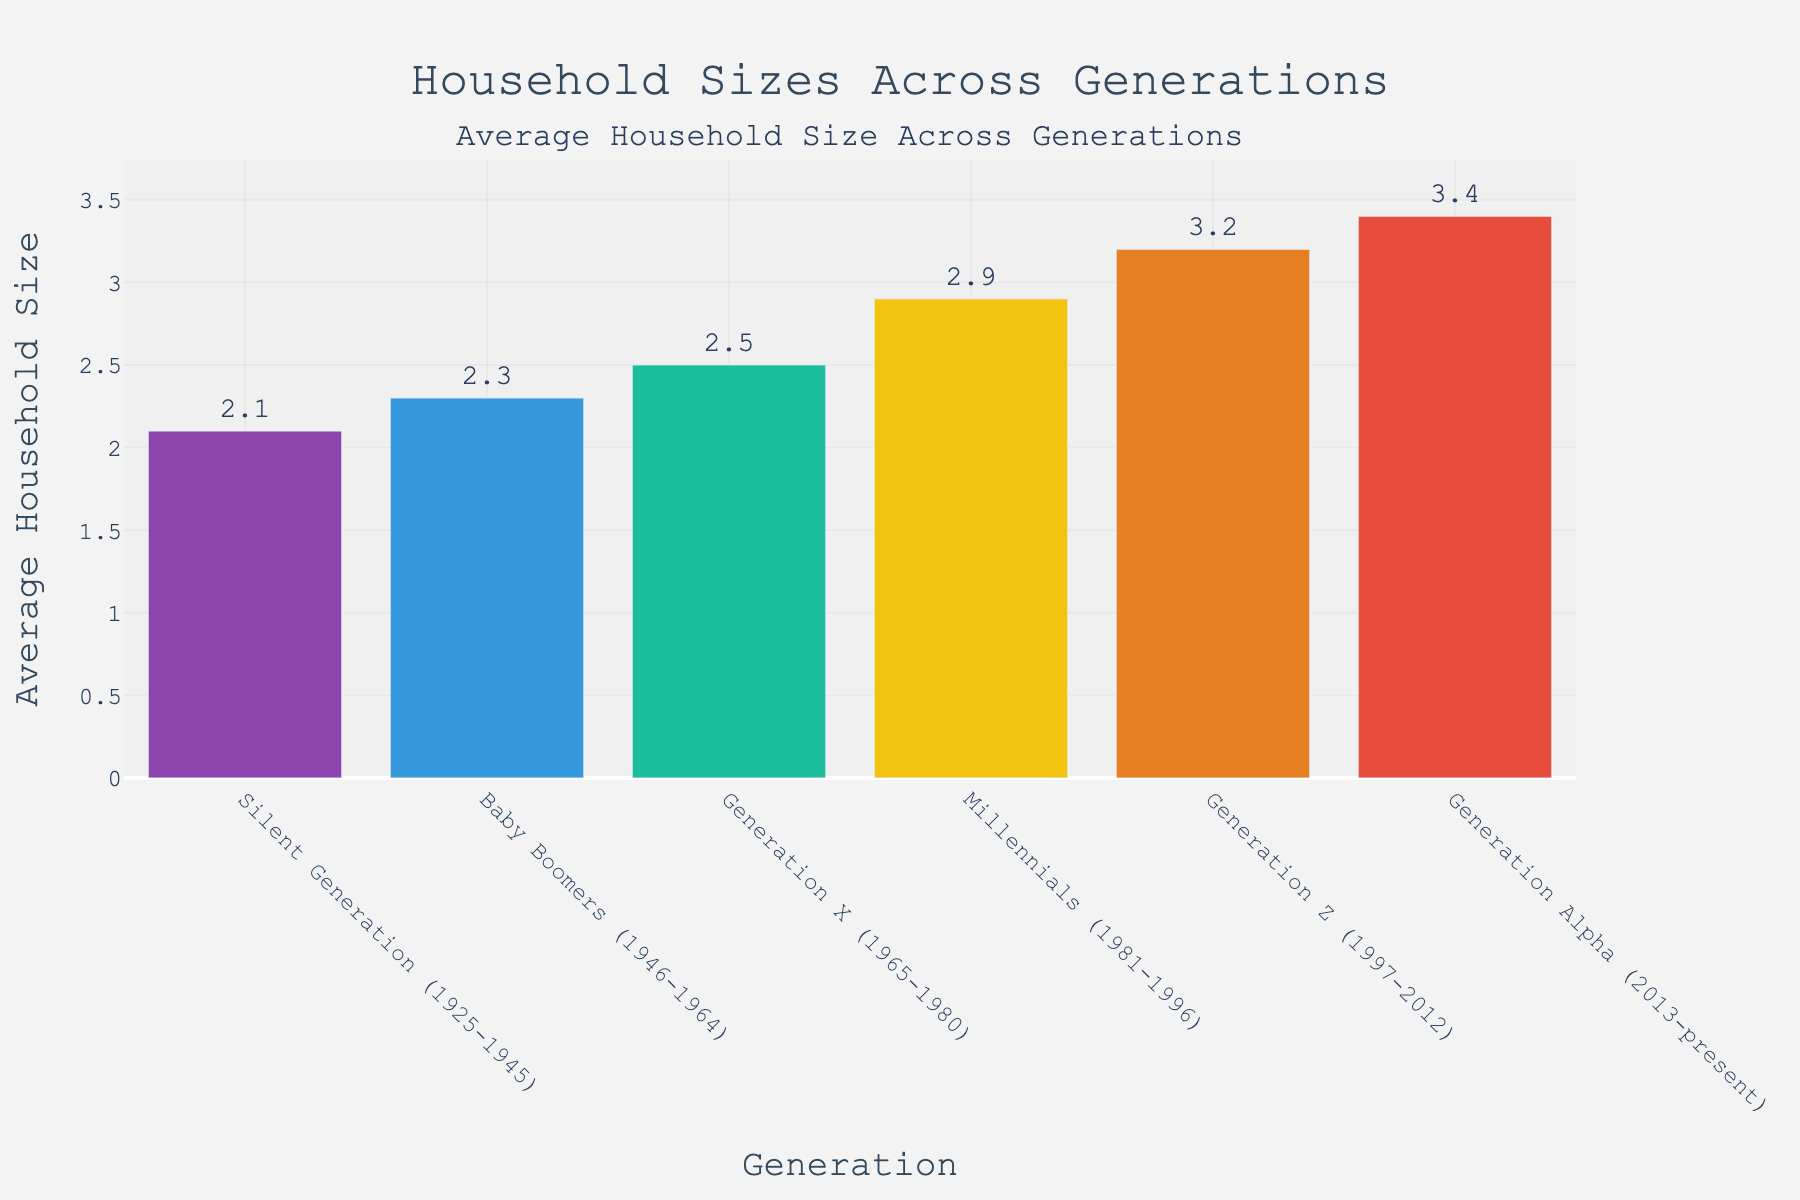What's the difference in average household size between the Silent Generation and Generation Alpha? First, identify the average household sizes for both generations from the figure: Silent Generation (2.1) and Generation Alpha (3.4). The difference is calculated as 3.4 - 2.1 = 1.3.
Answer: 1.3 Which generation has the smallest average household size? By examining the heights of the bars in the figure, the Silent Generation has the smallest average household size, which is 2.1.
Answer: Silent Generation How many generations have an average household size greater than 2.5? By inspecting the figure, count the generations with average household sizes greater than 2.5: Millennials, Generation Z, and Generation Alpha. There are 3 generations.
Answer: 3 Which generation shows the largest increase in average household size compared to the previous generation? Compare the differences between consecutive generations: Silent-Boomers (2.3-2.1=0.2), Boomers-X (2.5-2.3=0.2), X-Millennials (2.9-2.5=0.4), Millennials-Z (3.2-2.9=0.3), Z-Alpha (3.4-3.2=0.2). The largest increase is from Generation X to Millennials (0.4).
Answer: Millennials By how much does the average household size of Generation Z exceed that of the Baby Boomers? Identify the average household sizes: Generation Z (3.2) and Baby Boomers (2.3). The difference is calculated as 3.2 - 2.3 = 0.9.
Answer: 0.9 What is the sum of the average household sizes of all generations presented in the figure? Add the average household sizes of all the generations: 2.1 (Silent) + 2.3 (Boomers) + 2.5 (Gen X) + 2.9 (Millennials) + 3.2 (Gen Z) + 3.4 (Gen Alpha) = 16.4.
Answer: 16.4 Which generation is represented by the highest bar in the figure? The highest bar represents Generation Alpha, as its average household size is 3.4, the largest among the generations displayed.
Answer: Generation Alpha Compare the average household sizes of Millennials and Generation X. Which one is greater and by how much? Identify the average household sizes: Millennials (2.9) and Generation X (2.5). Millennials' household size is greater. The difference is 2.9 - 2.5 = 0.4.
Answer: Millennials, 0.4 How does the average household size of the Silent Generation compare to the general trend shown by later generations? The Silent Generation has the smallest household size (2.1), and there is a general increasing trend in household sizes in later generations up to Generation Alpha (3.4).
Answer: It is smaller than all later generations 